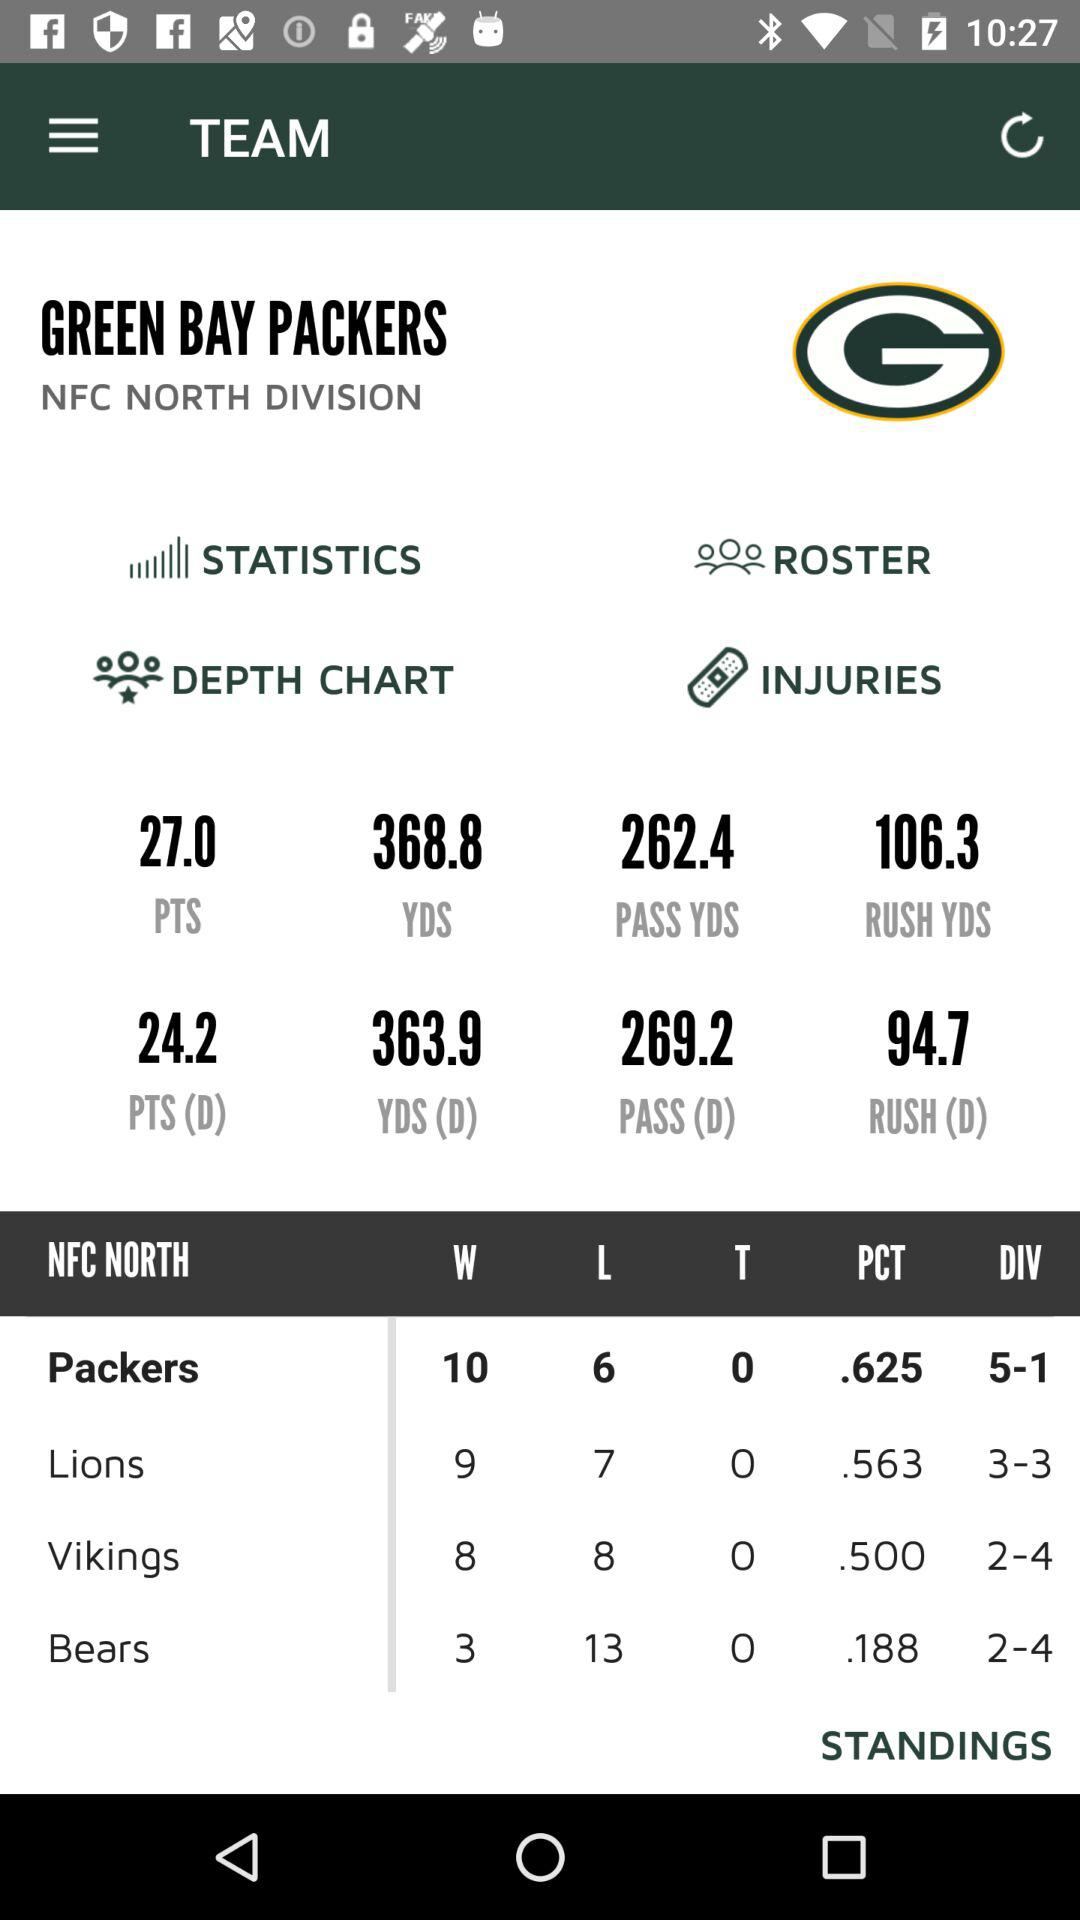How many more points does the Packers have than the Bears?
Answer the question using a single word or phrase. 7 